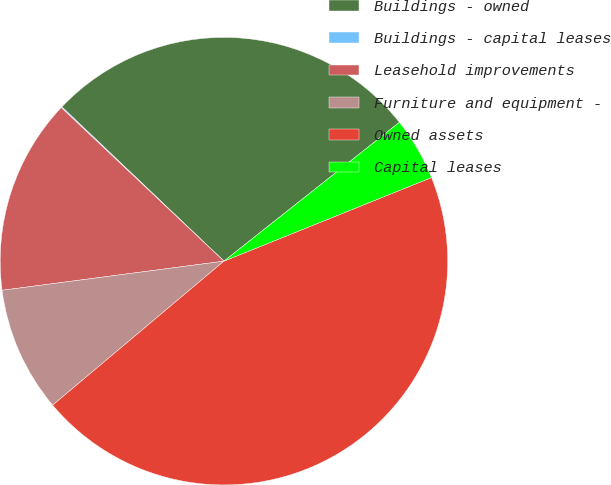Convert chart to OTSL. <chart><loc_0><loc_0><loc_500><loc_500><pie_chart><fcel>Buildings - owned<fcel>Buildings - capital leases<fcel>Leasehold improvements<fcel>Furniture and equipment -<fcel>Owned assets<fcel>Capital leases<nl><fcel>27.24%<fcel>0.07%<fcel>14.12%<fcel>9.05%<fcel>44.97%<fcel>4.56%<nl></chart> 